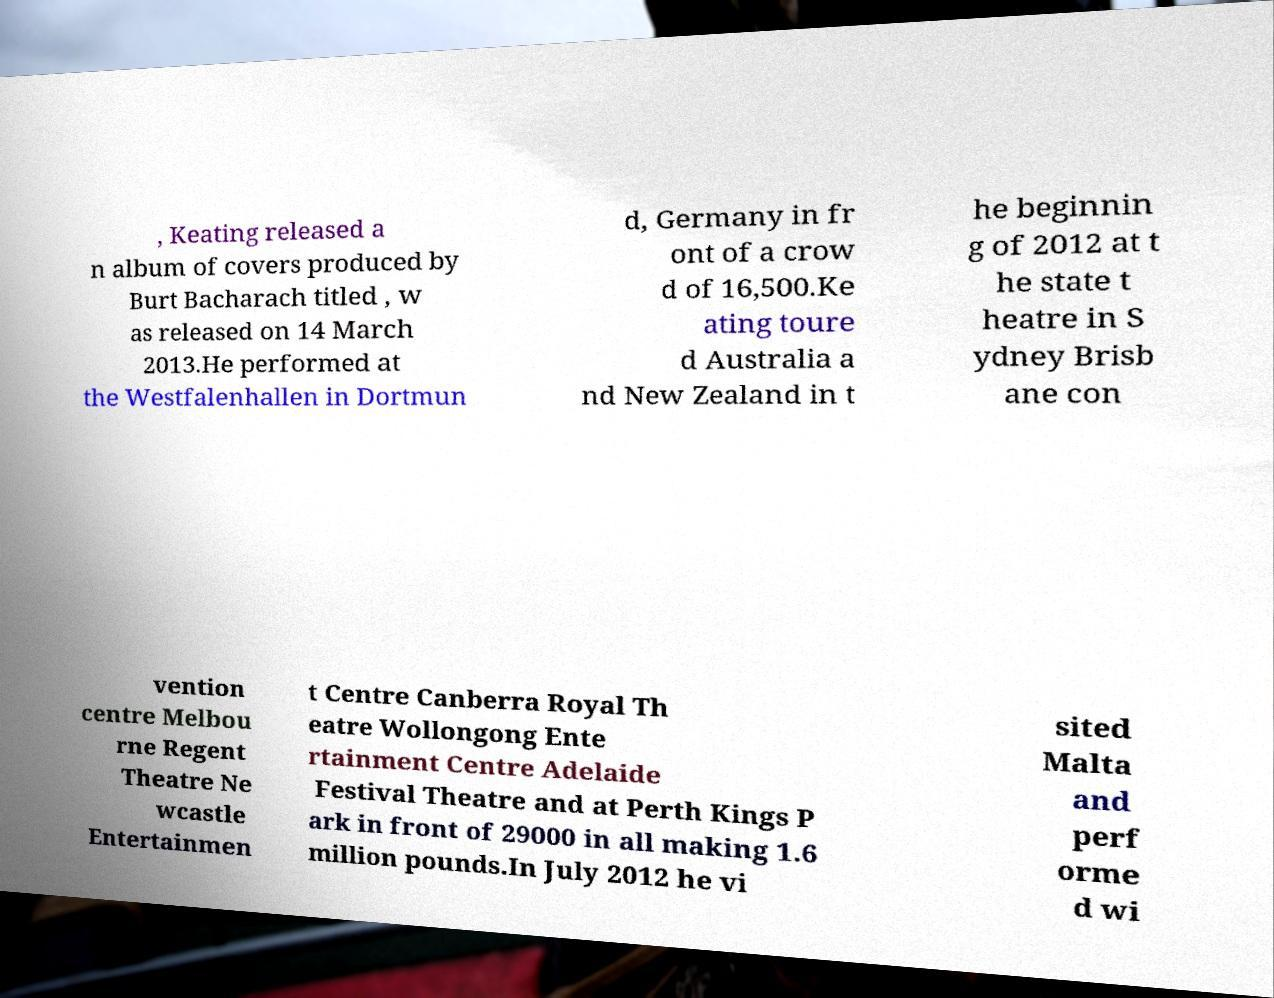Can you accurately transcribe the text from the provided image for me? , Keating released a n album of covers produced by Burt Bacharach titled , w as released on 14 March 2013.He performed at the Westfalenhallen in Dortmun d, Germany in fr ont of a crow d of 16,500.Ke ating toure d Australia a nd New Zealand in t he beginnin g of 2012 at t he state t heatre in S ydney Brisb ane con vention centre Melbou rne Regent Theatre Ne wcastle Entertainmen t Centre Canberra Royal Th eatre Wollongong Ente rtainment Centre Adelaide Festival Theatre and at Perth Kings P ark in front of 29000 in all making 1.6 million pounds.In July 2012 he vi sited Malta and perf orme d wi 